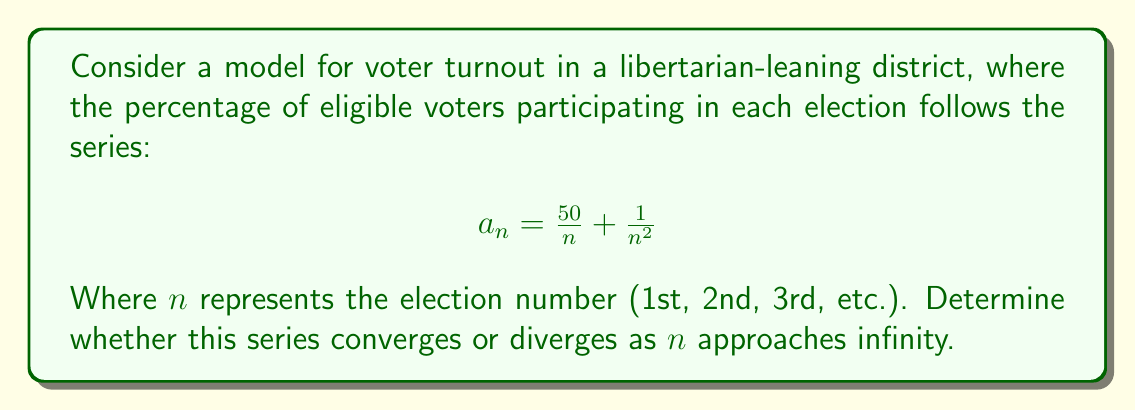Could you help me with this problem? To determine the convergence of this series, we'll use the limit comparison test with a known series. Let's break this down step-by-step:

1) Our series is of the form:
   $$\sum_{n=1}^{\infty} \left(\frac{50}{n} + \frac{1}{n^2}\right)$$

2) We can compare this to the harmonic series $\sum_{n=1}^{\infty} \frac{1}{n}$, which is known to diverge.

3) Let's call our series $a_n$ and the harmonic series $b_n$. We'll compute the limit of their ratio:

   $$\lim_{n \to \infty} \frac{a_n}{b_n} = \lim_{n \to \infty} \frac{\frac{50}{n} + \frac{1}{n^2}}{\frac{1}{n}}$$

4) Simplify:
   $$\lim_{n \to \infty} \frac{50 + \frac{1}{n}}{1} = \lim_{n \to \infty} \left(50 + \frac{1}{n}\right) = 50$$

5) Since this limit exists and is non-zero (in fact, it's greater than zero), by the limit comparison test, our series converges if and only if the harmonic series converges.

6) We know that the harmonic series diverges.

Therefore, since the limit of the ratio exists and is non-zero, and the harmonic series diverges, our series must also diverge.

This implies that in this model, the sum of voter turnout percentages over an infinite number of elections would grow without bound, which is not practically possible but mathematically interesting in the context of the series.
Answer: The series diverges. 